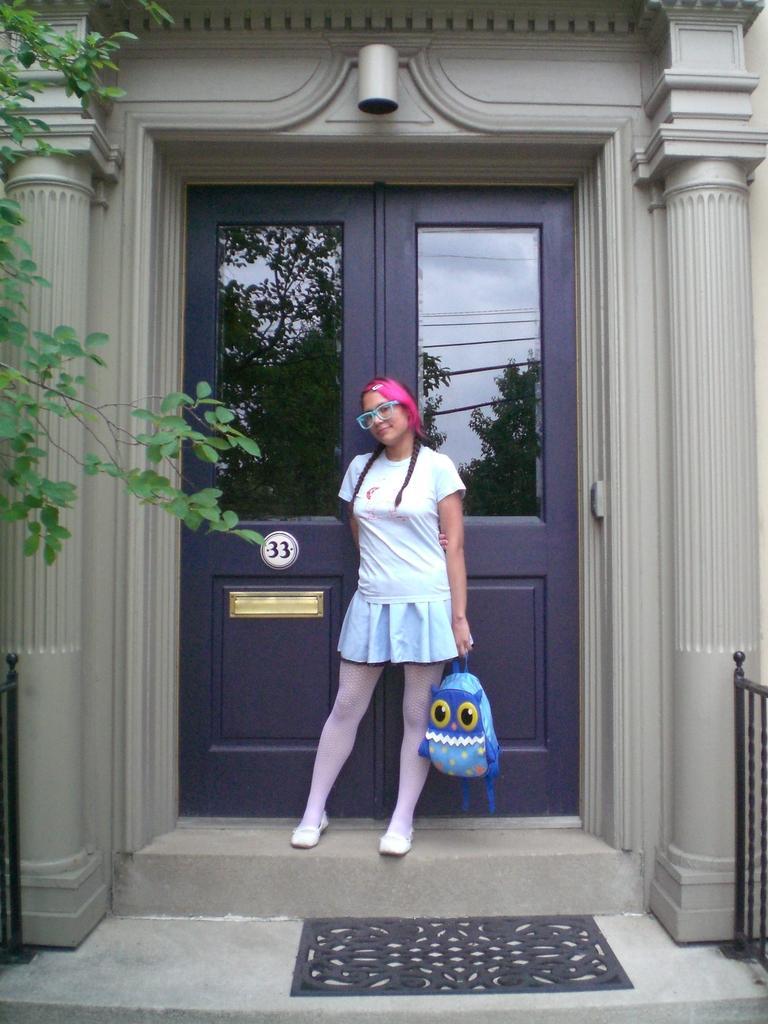Describe this image in one or two sentences. In this picture I can see a woman standing and holding a bag, there are pillars, mat, doors, iron grilles, this is looking like a house, and there is a reflection of trees, cables and sky. 